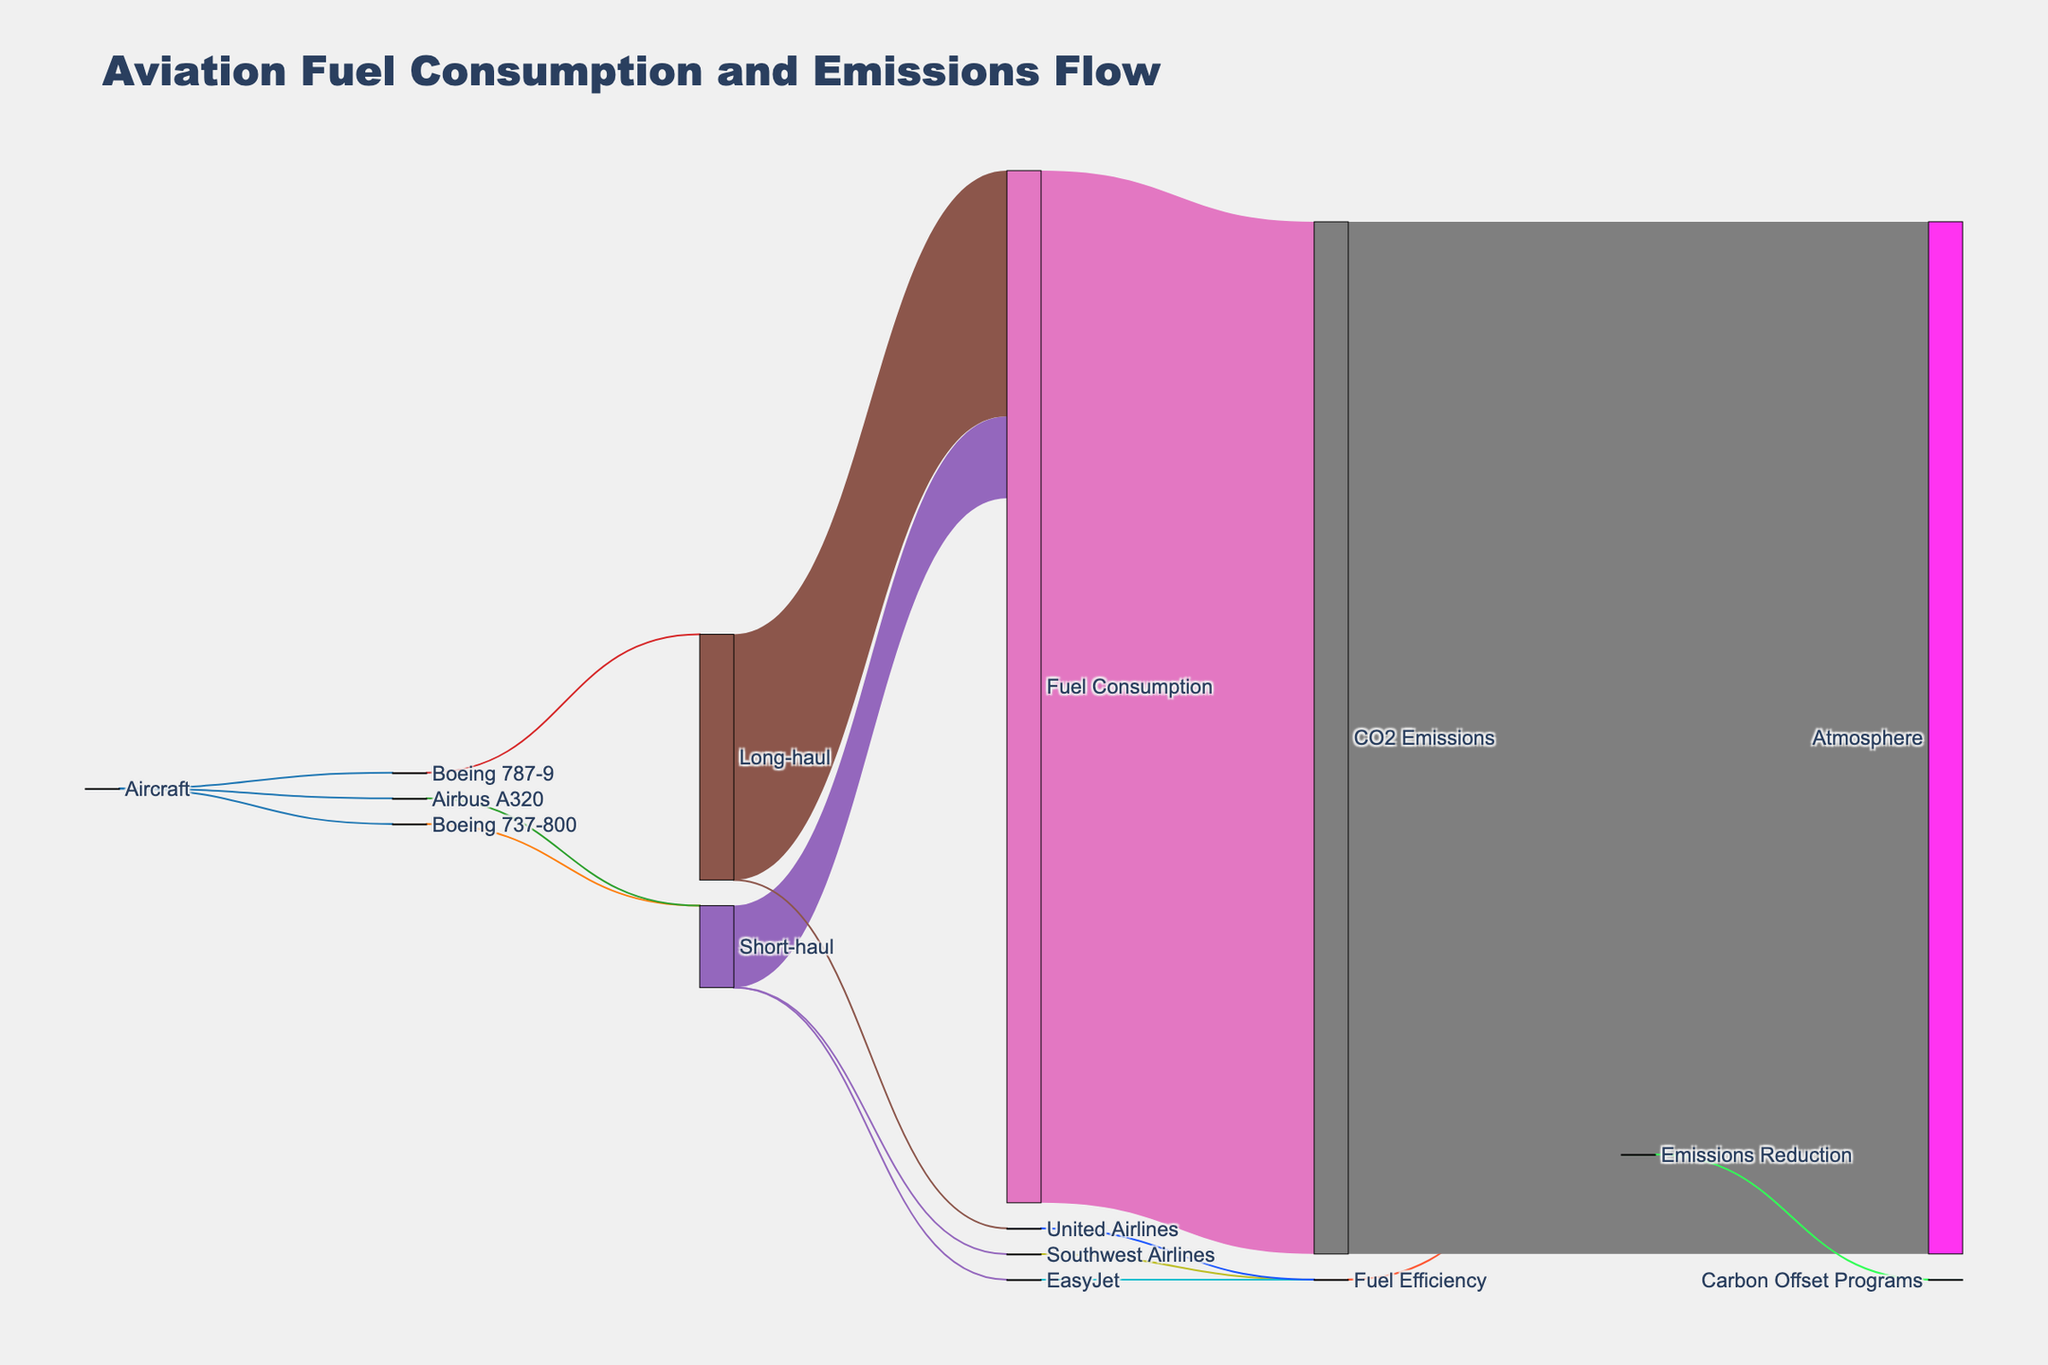What types of aircraft are displayed in the diagram? The figure shows nodes labeled with different aircraft types. Under the 'Aircraft' node, we see 'Boeing 737-800', 'Airbus A320', and 'Boeing 787-9'.
Answer: Boeing 737-800, Airbus A320, Boeing 787-9 Which aircraft is associated with long-haul routes? The node for 'Boeing 787-9' is connected to 'Long-haul', indicating that this aircraft type is associated with long-haul routes.
Answer: Boeing 787-9 How much fuel consumption is associated with short-haul routes? From the node labeled 'Short-haul', there is a link to 'Fuel Consumption' with a value of 15000.
Answer: 15000 Which airlines operate short-haul routes? 'Short-haul' branches into 'Southwest Airlines' and 'EasyJet', indicating they operate short-haul routes.
Answer: Southwest Airlines, EasyJet What is the fuel efficiency of United Airlines? The 'United Airlines' node connects to 'Fuel Efficiency' with a value indicating the efficiency. The diagram shows 'United Airlines' with a fuel efficiency value of 6.8.
Answer: 6.8 Compare the fuel efficiencies of Southwest Airlines and EasyJet. 'Southwest Airlines' has a fuel efficiency of 7.5 while 'EasyJet' has a fuel efficiency of 8.2, as shown by the links from these airlines to 'Fuel Efficiency'.
Answer: EasyJet has higher fuel efficiency than Southwest Airlines What is the final destination of the CO2 emissions in the diagram? The 'CO2 Emissions' node links directly to 'Atmosphere', indicating that all CO2 emissions end up in the atmosphere.
Answer: Atmosphere What is the total amount of CO2 emissions shown in the diagram? The link from 'Fuel Consumption' to 'CO2 Emissions' has a value of 189000, indicating the total CO2 emissions.
Answer: 189000 How much emission reduction is achieved through carbon offset programs? From the 'Emissions Reduction' node, there is a connection to 'Carbon Offset Programs' with a value of 22.5, showing the reduction amount.
Answer: 22.5 